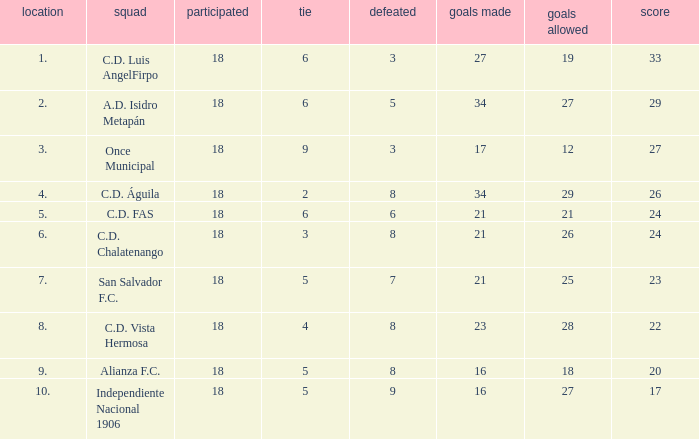For Once Municipal, what were the goals scored that had less than 27 points and greater than place 1? None. Help me parse the entirety of this table. {'header': ['location', 'squad', 'participated', 'tie', 'defeated', 'goals made', 'goals allowed', 'score'], 'rows': [['1.', 'C.D. Luis AngelFirpo', '18', '6', '3', '27', '19', '33'], ['2.', 'A.D. Isidro Metapán', '18', '6', '5', '34', '27', '29'], ['3.', 'Once Municipal', '18', '9', '3', '17', '12', '27'], ['4.', 'C.D. Águila', '18', '2', '8', '34', '29', '26'], ['5.', 'C.D. FAS', '18', '6', '6', '21', '21', '24'], ['6.', 'C.D. Chalatenango', '18', '3', '8', '21', '26', '24'], ['7.', 'San Salvador F.C.', '18', '5', '7', '21', '25', '23'], ['8.', 'C.D. Vista Hermosa', '18', '4', '8', '23', '28', '22'], ['9.', 'Alianza F.C.', '18', '5', '8', '16', '18', '20'], ['10.', 'Independiente Nacional 1906', '18', '5', '9', '16', '27', '17']]} 